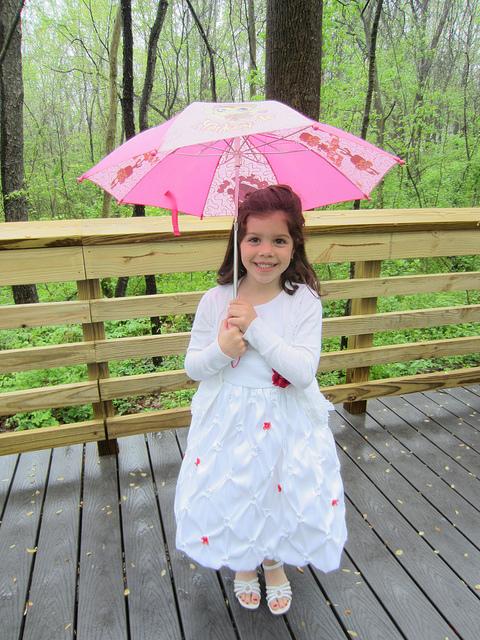Is the little girl crying?
Short answer required. No. What is the girl standing on?
Quick response, please. Bridge. What color of umbrella is this little girl holding?
Give a very brief answer. Pink. 